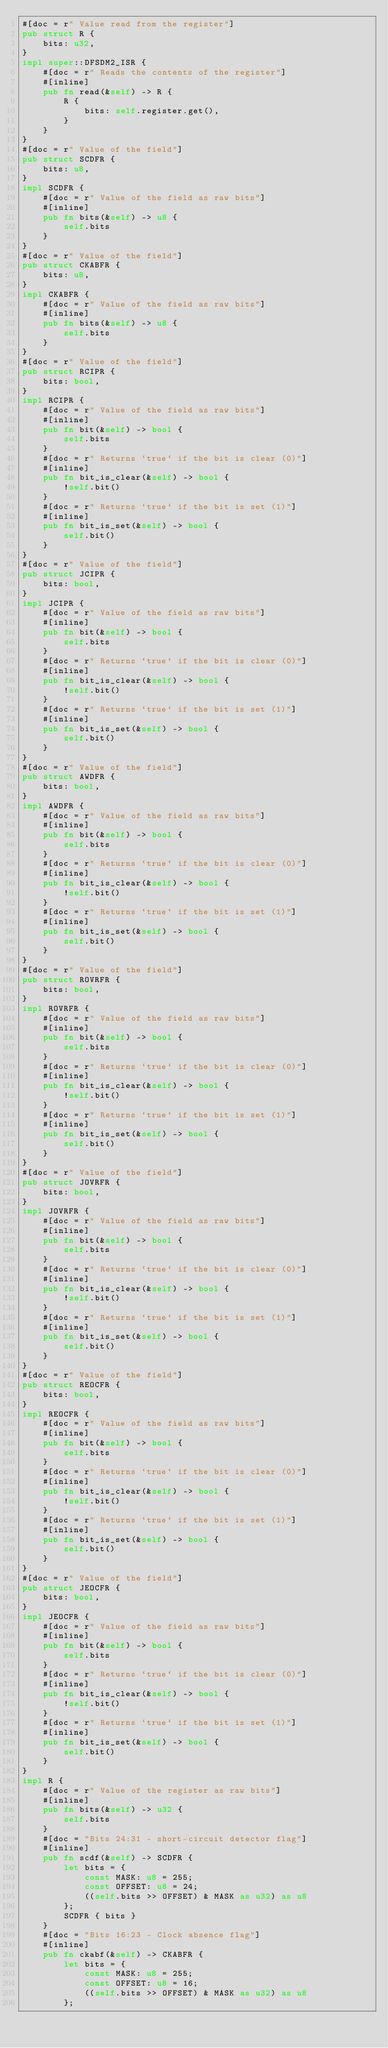Convert code to text. <code><loc_0><loc_0><loc_500><loc_500><_Rust_>#[doc = r" Value read from the register"]
pub struct R {
    bits: u32,
}
impl super::DFSDM2_ISR {
    #[doc = r" Reads the contents of the register"]
    #[inline]
    pub fn read(&self) -> R {
        R {
            bits: self.register.get(),
        }
    }
}
#[doc = r" Value of the field"]
pub struct SCDFR {
    bits: u8,
}
impl SCDFR {
    #[doc = r" Value of the field as raw bits"]
    #[inline]
    pub fn bits(&self) -> u8 {
        self.bits
    }
}
#[doc = r" Value of the field"]
pub struct CKABFR {
    bits: u8,
}
impl CKABFR {
    #[doc = r" Value of the field as raw bits"]
    #[inline]
    pub fn bits(&self) -> u8 {
        self.bits
    }
}
#[doc = r" Value of the field"]
pub struct RCIPR {
    bits: bool,
}
impl RCIPR {
    #[doc = r" Value of the field as raw bits"]
    #[inline]
    pub fn bit(&self) -> bool {
        self.bits
    }
    #[doc = r" Returns `true` if the bit is clear (0)"]
    #[inline]
    pub fn bit_is_clear(&self) -> bool {
        !self.bit()
    }
    #[doc = r" Returns `true` if the bit is set (1)"]
    #[inline]
    pub fn bit_is_set(&self) -> bool {
        self.bit()
    }
}
#[doc = r" Value of the field"]
pub struct JCIPR {
    bits: bool,
}
impl JCIPR {
    #[doc = r" Value of the field as raw bits"]
    #[inline]
    pub fn bit(&self) -> bool {
        self.bits
    }
    #[doc = r" Returns `true` if the bit is clear (0)"]
    #[inline]
    pub fn bit_is_clear(&self) -> bool {
        !self.bit()
    }
    #[doc = r" Returns `true` if the bit is set (1)"]
    #[inline]
    pub fn bit_is_set(&self) -> bool {
        self.bit()
    }
}
#[doc = r" Value of the field"]
pub struct AWDFR {
    bits: bool,
}
impl AWDFR {
    #[doc = r" Value of the field as raw bits"]
    #[inline]
    pub fn bit(&self) -> bool {
        self.bits
    }
    #[doc = r" Returns `true` if the bit is clear (0)"]
    #[inline]
    pub fn bit_is_clear(&self) -> bool {
        !self.bit()
    }
    #[doc = r" Returns `true` if the bit is set (1)"]
    #[inline]
    pub fn bit_is_set(&self) -> bool {
        self.bit()
    }
}
#[doc = r" Value of the field"]
pub struct ROVRFR {
    bits: bool,
}
impl ROVRFR {
    #[doc = r" Value of the field as raw bits"]
    #[inline]
    pub fn bit(&self) -> bool {
        self.bits
    }
    #[doc = r" Returns `true` if the bit is clear (0)"]
    #[inline]
    pub fn bit_is_clear(&self) -> bool {
        !self.bit()
    }
    #[doc = r" Returns `true` if the bit is set (1)"]
    #[inline]
    pub fn bit_is_set(&self) -> bool {
        self.bit()
    }
}
#[doc = r" Value of the field"]
pub struct JOVRFR {
    bits: bool,
}
impl JOVRFR {
    #[doc = r" Value of the field as raw bits"]
    #[inline]
    pub fn bit(&self) -> bool {
        self.bits
    }
    #[doc = r" Returns `true` if the bit is clear (0)"]
    #[inline]
    pub fn bit_is_clear(&self) -> bool {
        !self.bit()
    }
    #[doc = r" Returns `true` if the bit is set (1)"]
    #[inline]
    pub fn bit_is_set(&self) -> bool {
        self.bit()
    }
}
#[doc = r" Value of the field"]
pub struct REOCFR {
    bits: bool,
}
impl REOCFR {
    #[doc = r" Value of the field as raw bits"]
    #[inline]
    pub fn bit(&self) -> bool {
        self.bits
    }
    #[doc = r" Returns `true` if the bit is clear (0)"]
    #[inline]
    pub fn bit_is_clear(&self) -> bool {
        !self.bit()
    }
    #[doc = r" Returns `true` if the bit is set (1)"]
    #[inline]
    pub fn bit_is_set(&self) -> bool {
        self.bit()
    }
}
#[doc = r" Value of the field"]
pub struct JEOCFR {
    bits: bool,
}
impl JEOCFR {
    #[doc = r" Value of the field as raw bits"]
    #[inline]
    pub fn bit(&self) -> bool {
        self.bits
    }
    #[doc = r" Returns `true` if the bit is clear (0)"]
    #[inline]
    pub fn bit_is_clear(&self) -> bool {
        !self.bit()
    }
    #[doc = r" Returns `true` if the bit is set (1)"]
    #[inline]
    pub fn bit_is_set(&self) -> bool {
        self.bit()
    }
}
impl R {
    #[doc = r" Value of the register as raw bits"]
    #[inline]
    pub fn bits(&self) -> u32 {
        self.bits
    }
    #[doc = "Bits 24:31 - short-circuit detector flag"]
    #[inline]
    pub fn scdf(&self) -> SCDFR {
        let bits = {
            const MASK: u8 = 255;
            const OFFSET: u8 = 24;
            ((self.bits >> OFFSET) & MASK as u32) as u8
        };
        SCDFR { bits }
    }
    #[doc = "Bits 16:23 - Clock absence flag"]
    #[inline]
    pub fn ckabf(&self) -> CKABFR {
        let bits = {
            const MASK: u8 = 255;
            const OFFSET: u8 = 16;
            ((self.bits >> OFFSET) & MASK as u32) as u8
        };</code> 